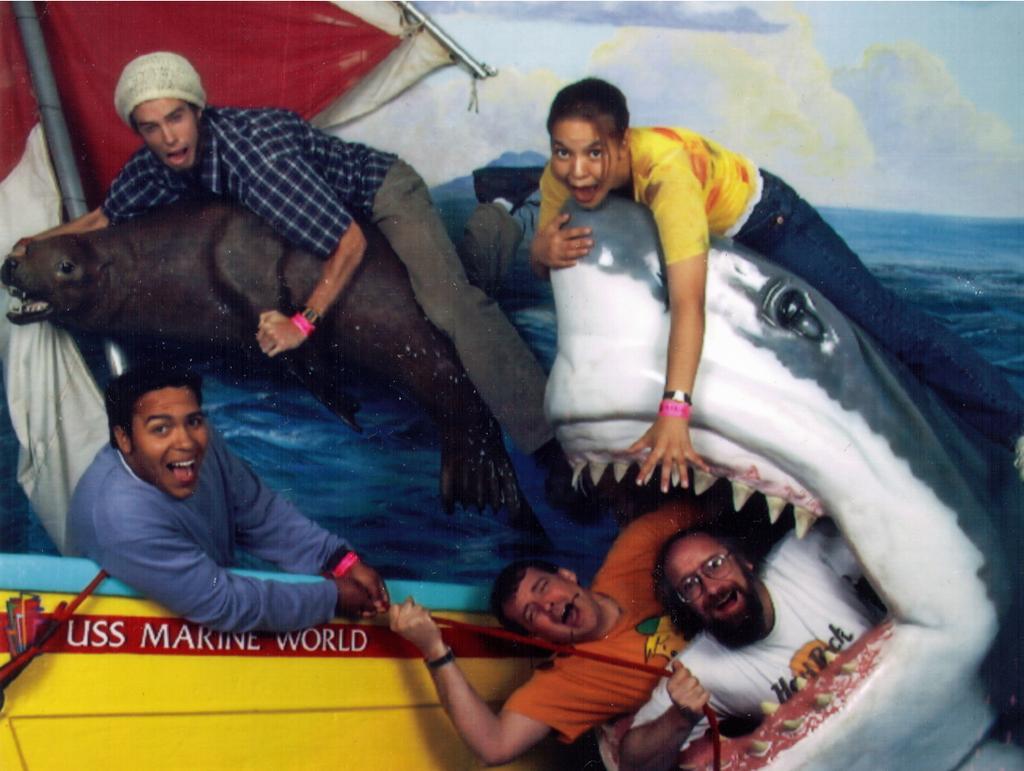In one or two sentences, can you explain what this image depicts? In the image there are statues of shark, seal and a boat. There are few people in the image. Behind them there is a wall with wallpaper. On the wallpaper there is water, sky with clouds and poles with flags. 